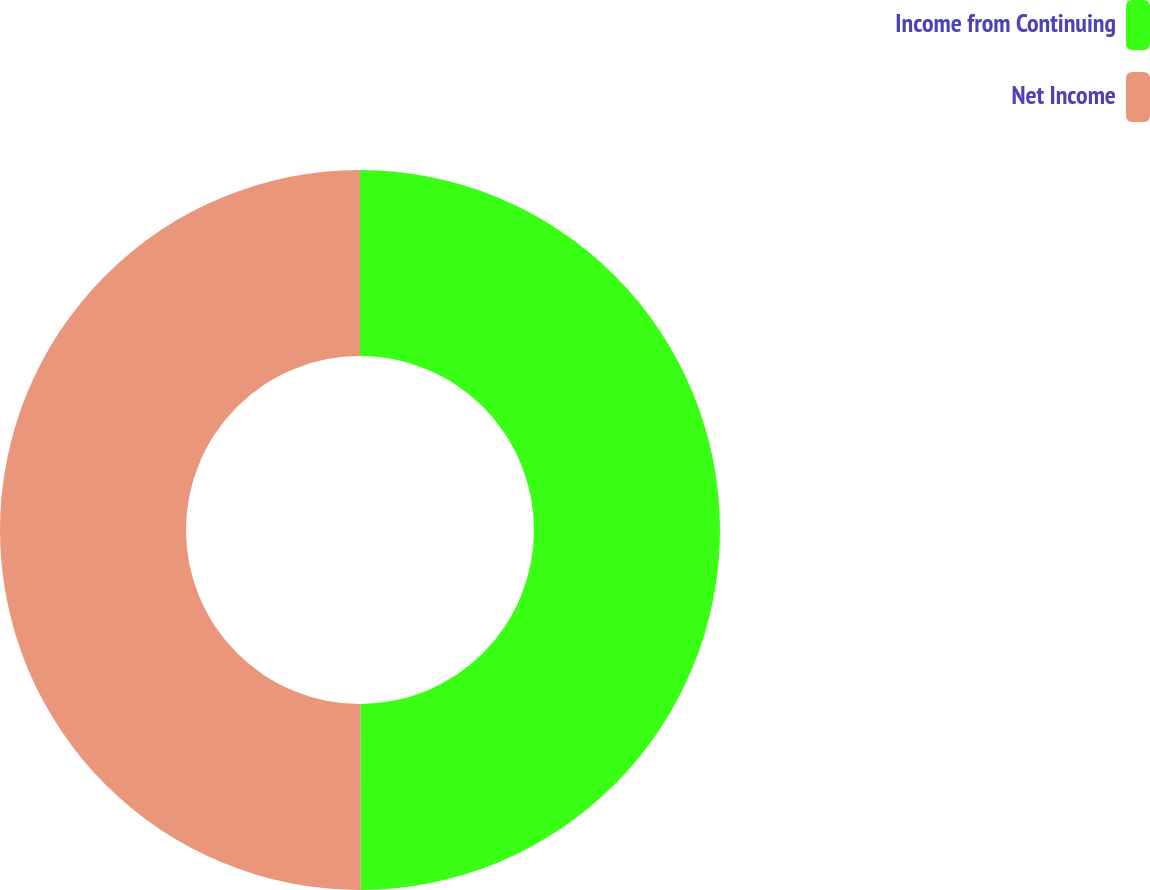Convert chart. <chart><loc_0><loc_0><loc_500><loc_500><pie_chart><fcel>Income from Continuing<fcel>Net Income<nl><fcel>49.97%<fcel>50.03%<nl></chart> 